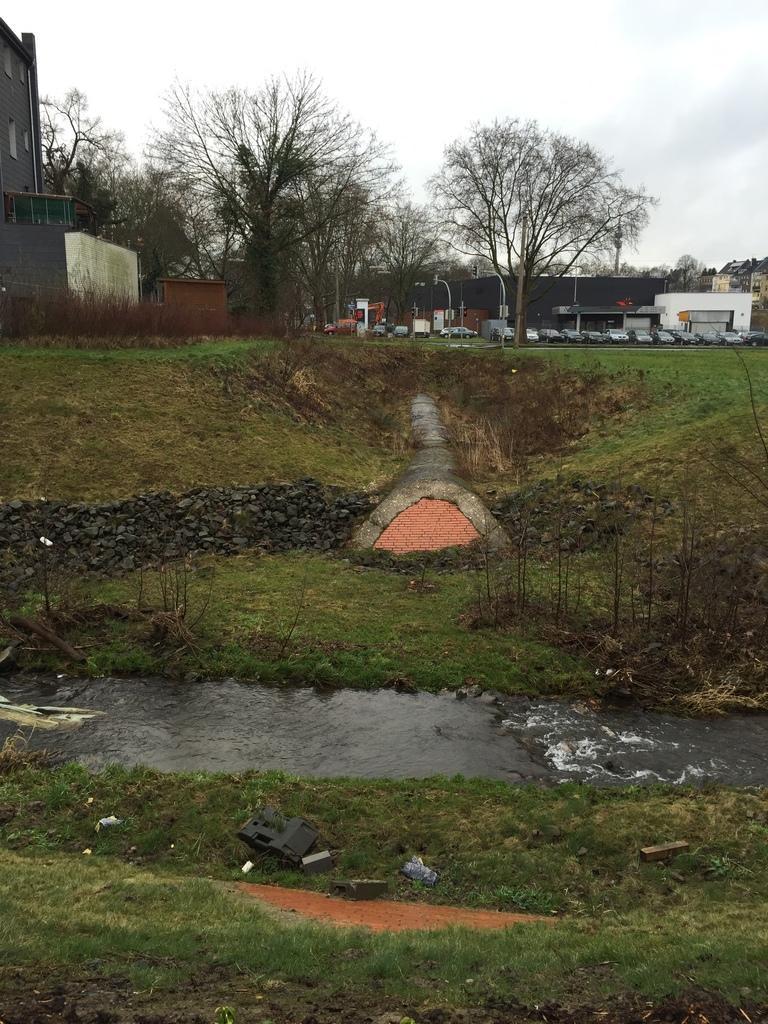Could you give a brief overview of what you see in this image? In this image, we can see water flow, grass, few objects, plants and stones. Background there are so many trees, houses, buildings, vehicles, poles and sky. 